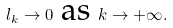<formula> <loc_0><loc_0><loc_500><loc_500>l _ { k } \rightarrow 0 \ \text {as} \ k \rightarrow + \infty .</formula> 